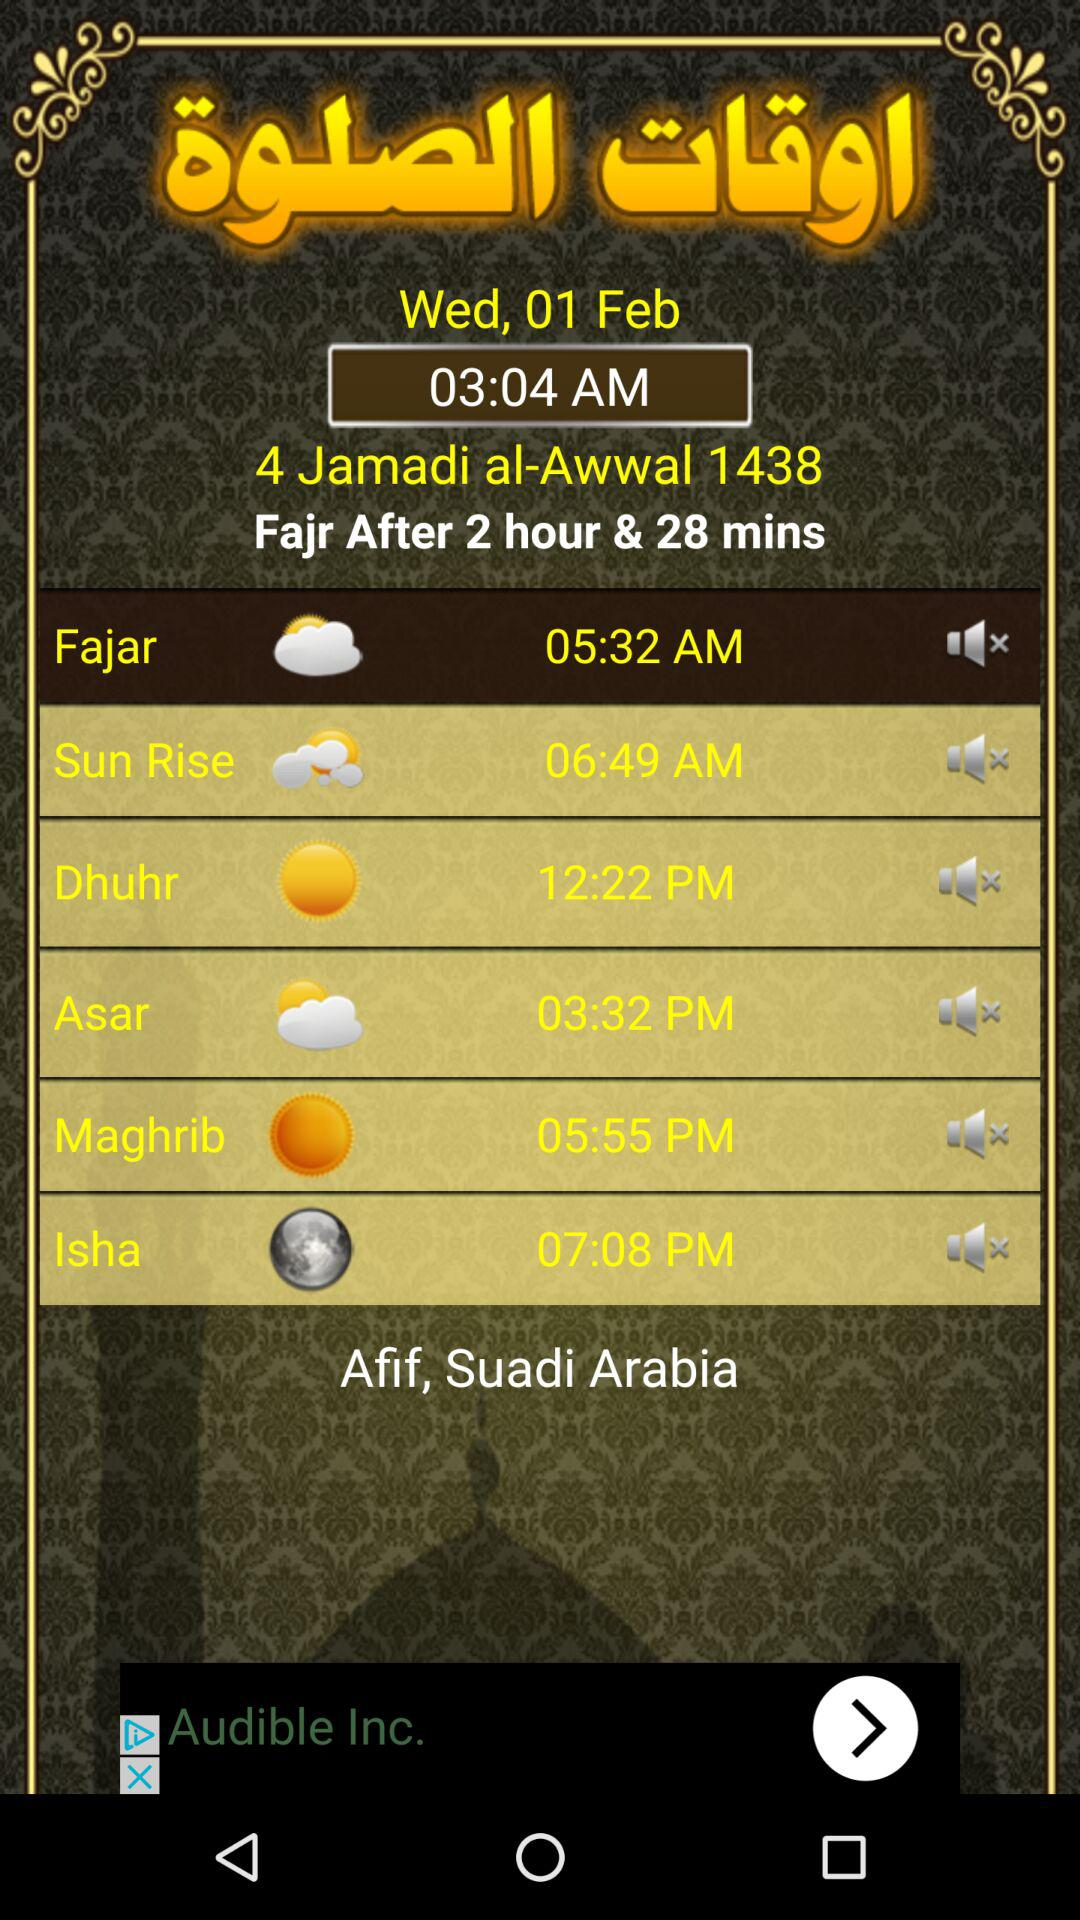What is the time for "Dhuhr"? The time for "Dhuhr" is 12:22 PM. 